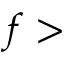<formula> <loc_0><loc_0><loc_500><loc_500>f ></formula> 